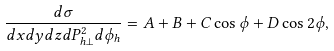<formula> <loc_0><loc_0><loc_500><loc_500>\frac { d \sigma } { d x d y d z d P ^ { 2 } _ { h \perp } d \phi _ { h } } = A + B + C \cos \phi + D \cos 2 \phi ,</formula> 